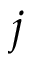<formula> <loc_0><loc_0><loc_500><loc_500>j</formula> 